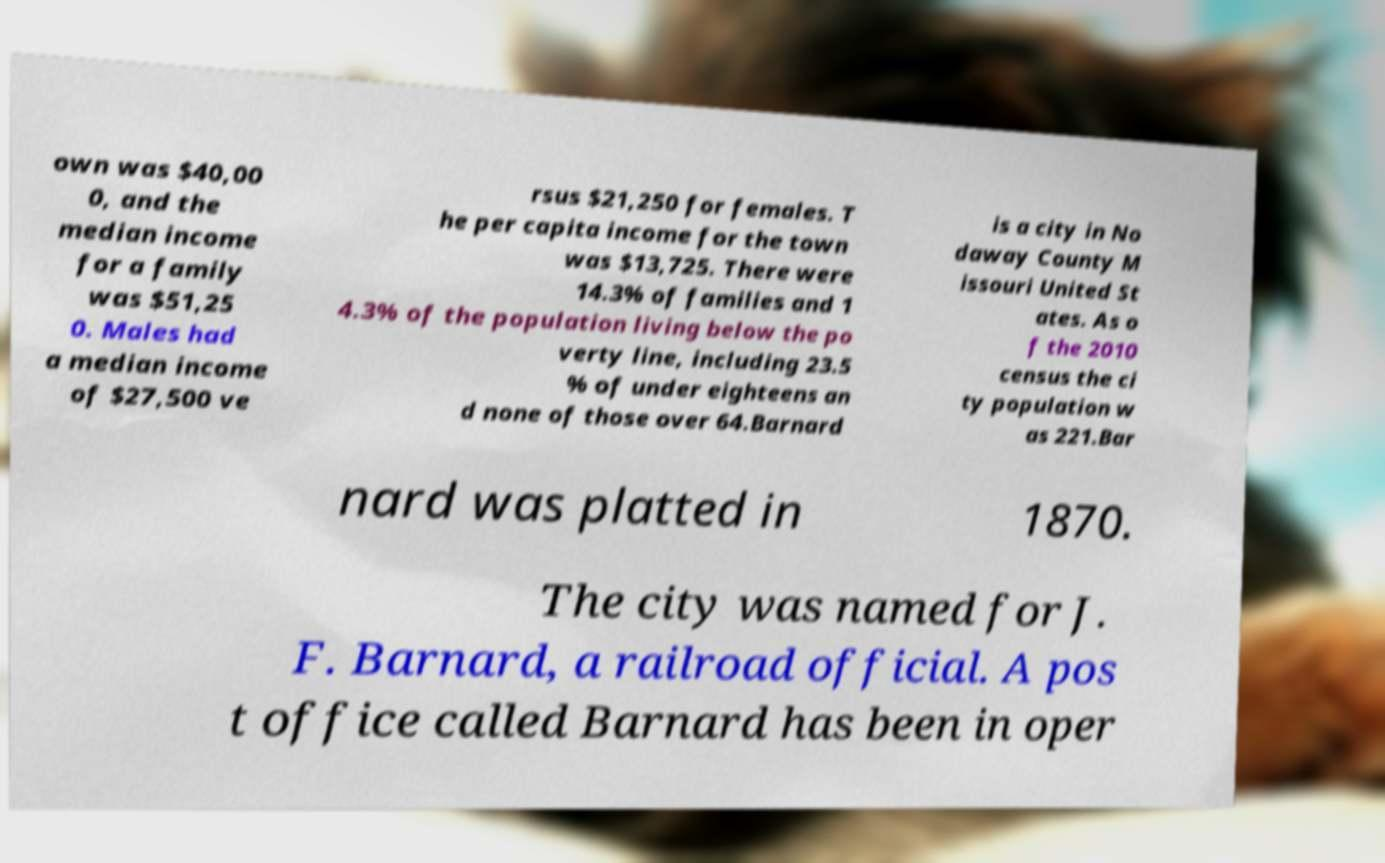Can you accurately transcribe the text from the provided image for me? own was $40,00 0, and the median income for a family was $51,25 0. Males had a median income of $27,500 ve rsus $21,250 for females. T he per capita income for the town was $13,725. There were 14.3% of families and 1 4.3% of the population living below the po verty line, including 23.5 % of under eighteens an d none of those over 64.Barnard is a city in No daway County M issouri United St ates. As o f the 2010 census the ci ty population w as 221.Bar nard was platted in 1870. The city was named for J. F. Barnard, a railroad official. A pos t office called Barnard has been in oper 